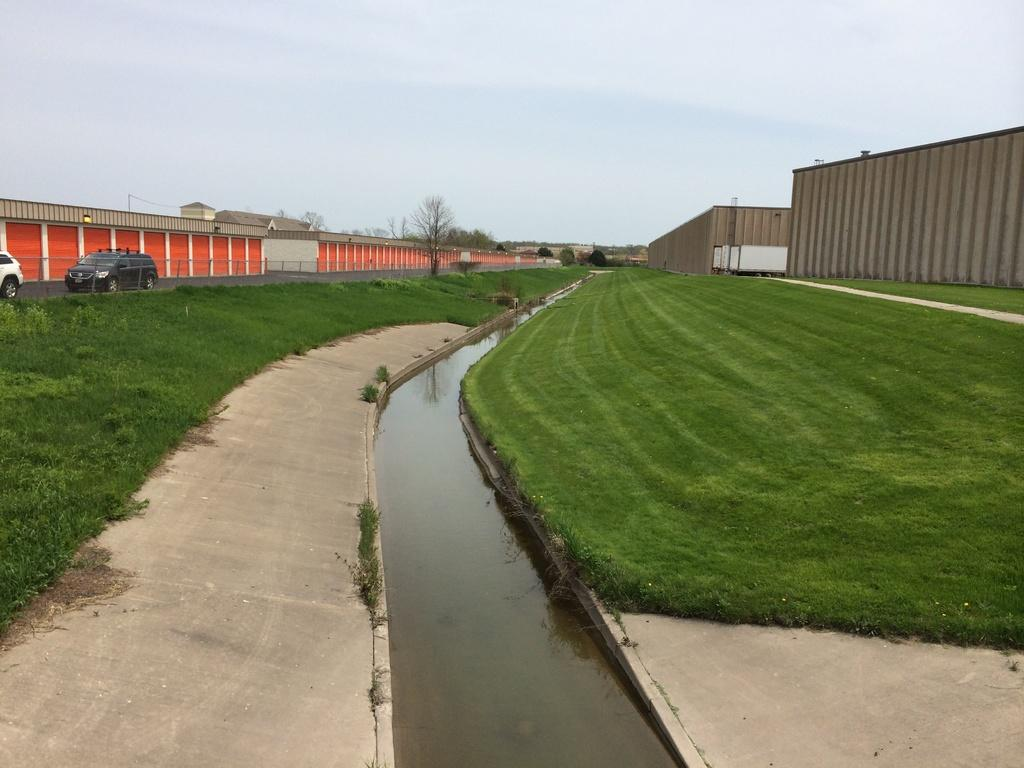What types of objects can be seen in the image? There are vehicles, trees, and containers in orange and brown colors in the image. What is the color of the sky in the image? The sky is in white and blue colors in the image. What type of barrier is present in the image? There is fencing in the image. What type of net can be seen in the image? There is no net present in the image. What type of clouds can be seen in the image? The sky is in white and blue colors in the image, but there are no clouds visible. --- 